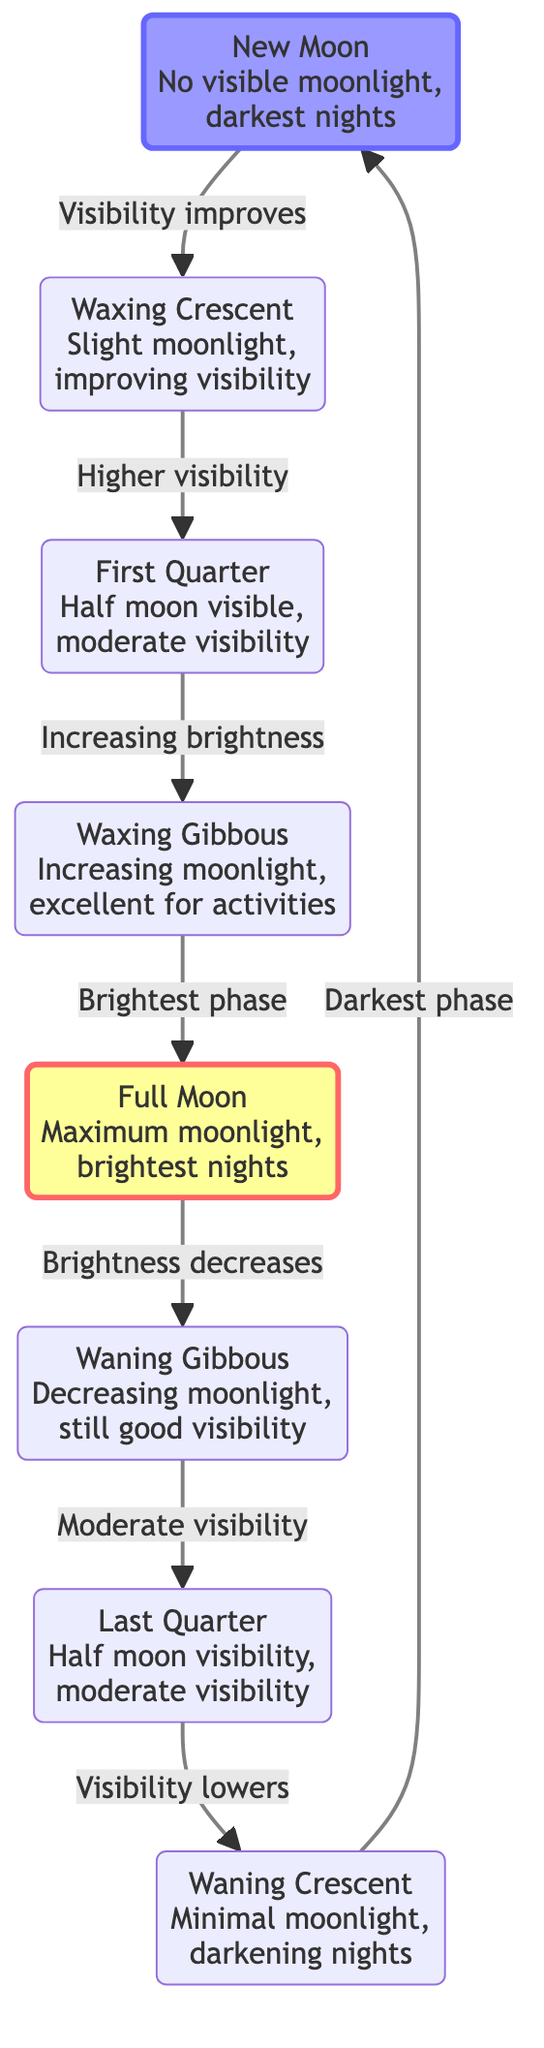What is the first phase after the New Moon? The diagram shows arrows indicating the flow from one phase to another. From "New Moon", the next phase indicated by the arrow is "Waxing Crescent".
Answer: Waxing Crescent How many total phases of the Moon are represented in the diagram? The diagram lists eight different phases connected in a cycle, including New Moon, Waxing Crescent, First Quarter, Waxing Gibbous, Full Moon, Waning Gibbous, Last Quarter, and Waning Crescent. Counting these, we find there are eight phases in total.
Answer: Eight Which phase is characterized by maximum moonlight? According to the diagram, "Full Moon" is highlighted as the phase with maximum moonlight. The description explicitly states that it is the "brightest nights".
Answer: Full Moon What happens to visibility after the Full Moon phase? The diagram shows that after "Full Moon", visibility decreases, leading to "Waning Gibbous". This indicates that while the Full Moon provides maximum visibility, it won't last long as the moonlight starts to decrease.
Answer: Decreases What is the visibility condition during the New Moon? The diagram specifies that during the "New Moon" phase, there is "No visible moonlight, darkest nights", indicating very poor visibility for night-time activities.
Answer: Darkest nights What phase offers excellent visibility for outdoor activities? The "Waxing Gibbous" phase is described in the diagram as providing "Increasing moonlight, excellent for activities", suggesting that this is the ideal phase for outdoor engagements due to good visibility.
Answer: Excellent for activities Which two phases provide moderate visibility? The diagram indicates "First Quarter" and "Last Quarter" both describe moderate visibility. Hence, they provide a similar level of visibility for night-time activities.
Answer: First Quarter and Last Quarter What is the relationship between Waxing Gibbous and Full Moon? The diagram shows a directional arrow from "Waxing Gibbous" to "Full Moon", indicating that Waxing Gibbous leads up to the Full Moon, marking it as a phase that increases brightness right before the brightest point, the Full Moon.
Answer: Increases brightness 